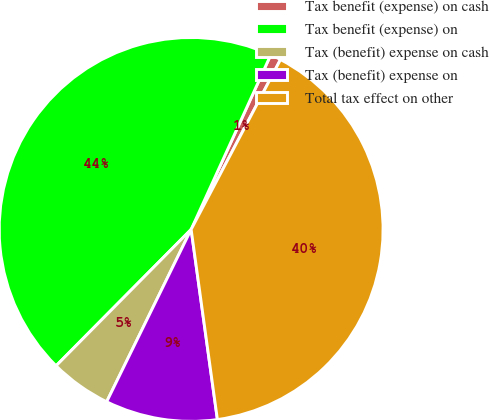Convert chart to OTSL. <chart><loc_0><loc_0><loc_500><loc_500><pie_chart><fcel>Tax benefit (expense) on cash<fcel>Tax benefit (expense) on<fcel>Tax (benefit) expense on cash<fcel>Tax (benefit) expense on<fcel>Total tax effect on other<nl><fcel>0.9%<fcel>44.39%<fcel>5.17%<fcel>9.44%<fcel>40.11%<nl></chart> 